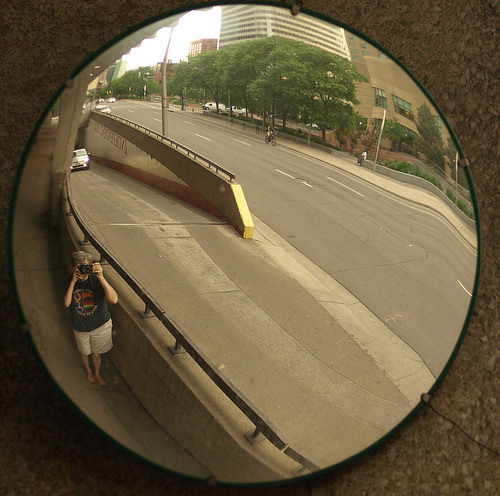<image>
Can you confirm if the person is in the street? No. The person is not contained within the street. These objects have a different spatial relationship. Where is the tourist in relation to the street? Is it in the street? No. The tourist is not contained within the street. These objects have a different spatial relationship. 